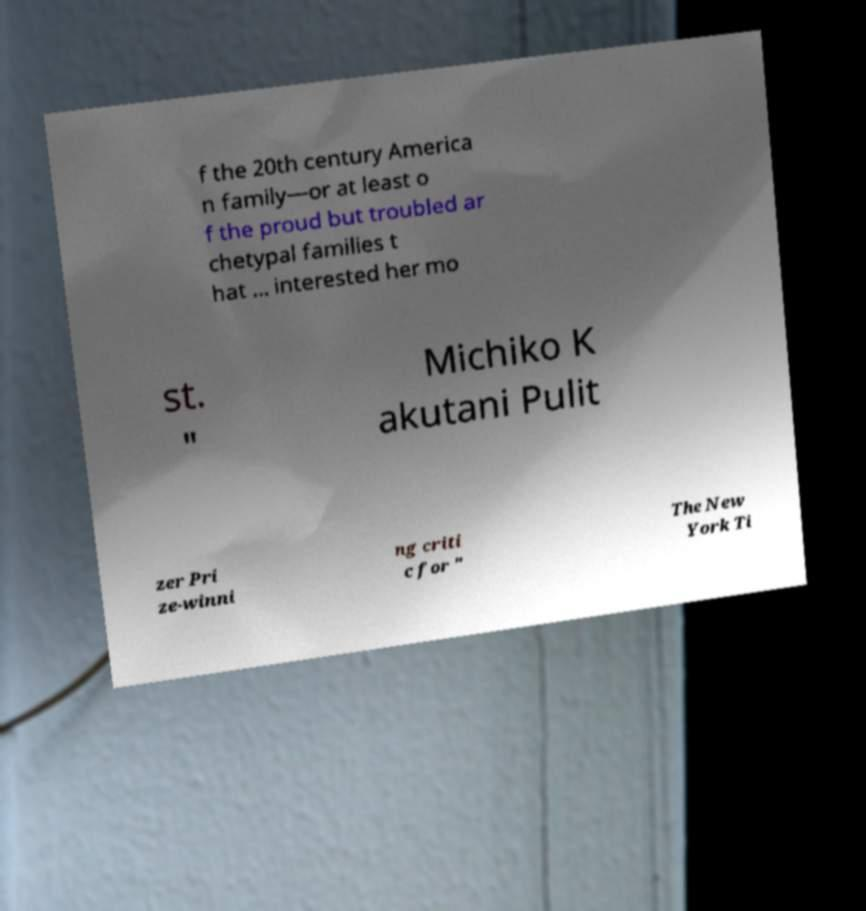Please identify and transcribe the text found in this image. f the 20th century America n family—or at least o f the proud but troubled ar chetypal families t hat ... interested her mo st. " Michiko K akutani Pulit zer Pri ze-winni ng criti c for " The New York Ti 